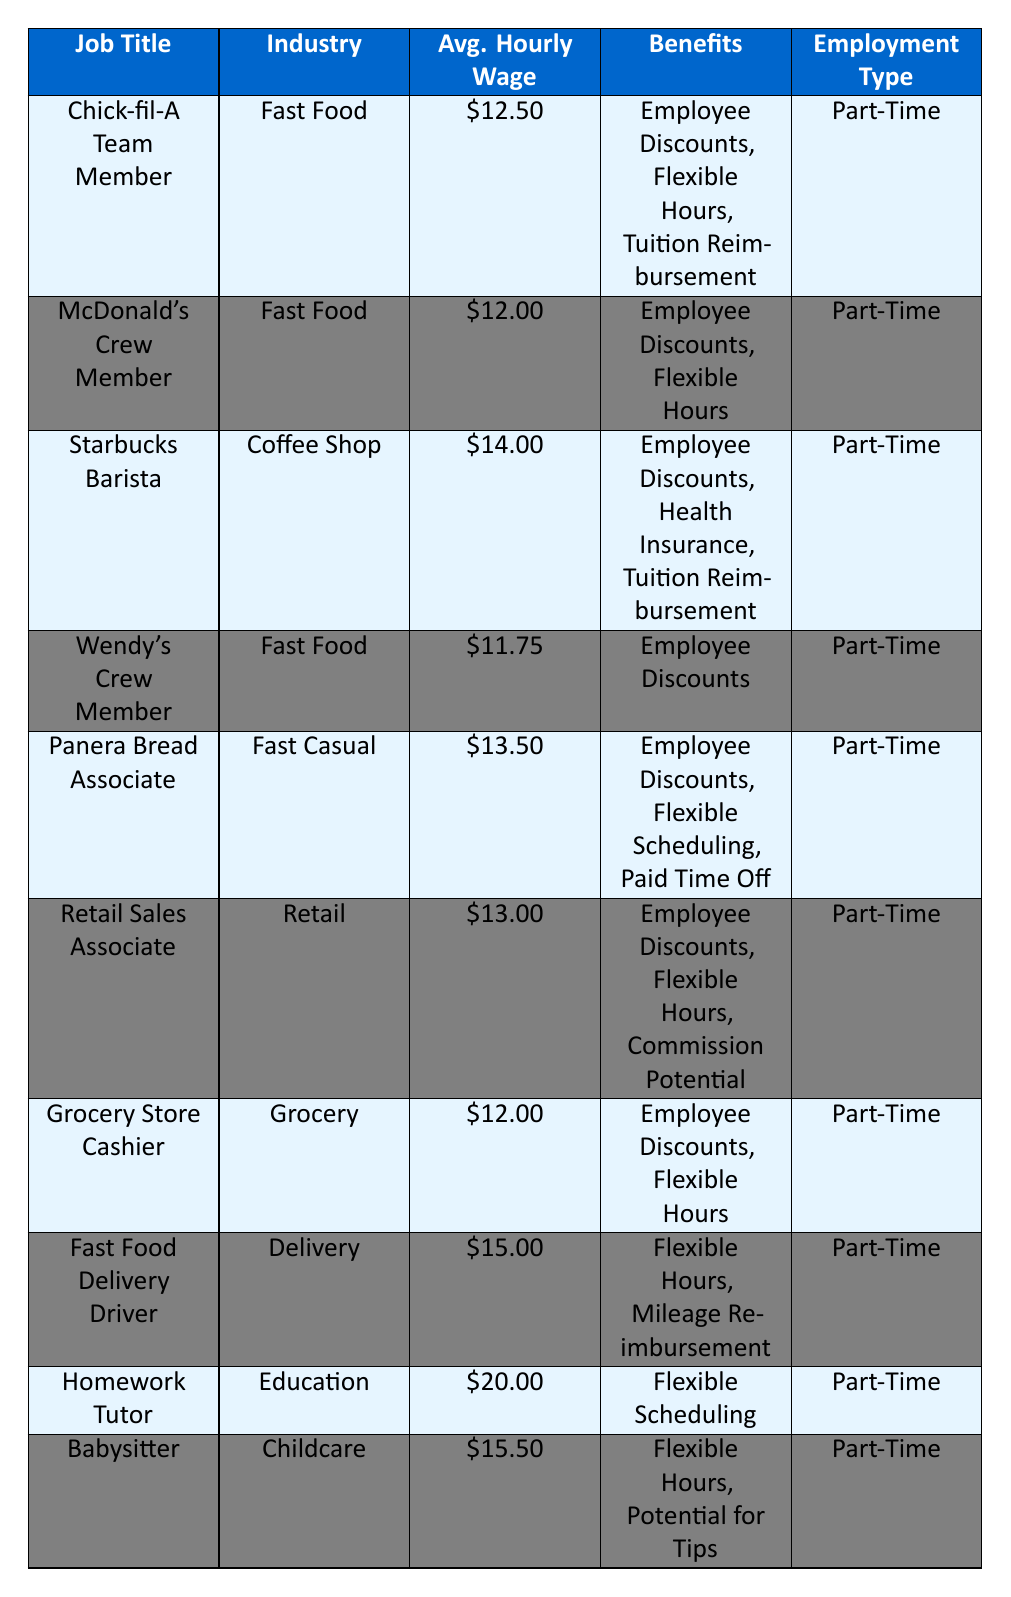What is the average hourly wage of a Chick-fil-A Team Member? The table shows that the average hourly wage for a Chick-fil-A Team Member is $12.50.
Answer: $12.50 Which position has the highest average hourly wage in the table? The Homework Tutor has the highest average hourly wage at $20.00.
Answer: Homework Tutor How much more does a Fast Food Delivery Driver earn compared to a Wendy's Crew Member? The Fast Food Delivery Driver earns $15.00 while Wendy's Crew Member earns $11.75. The difference is $15.00 - $11.75 = $3.25.
Answer: $3.25 Does Starbucks Barista offer tuition reimbursement as a benefit? Yes, the table indicates that Starbucks Barista includes tuition reimbursement in its benefits.
Answer: Yes What is the average hourly wage for all the fast food jobs listed? The fast food jobs are Chick-fil-A Team Member ($12.50), McDonald's Crew Member ($12.00), and Wendy's Crew Member ($11.75). The average is (12.50 + 12.00 + 11.75) / 3 = 12.08.
Answer: $12.08 What is the difference in average hourly wage between the highest paying job and the lowest paying job in the table? The highest paying job is Homework Tutor at $20.00, and the lowest paying job is Wendy's Crew Member at $11.75. The difference is $20.00 - $11.75 = $8.25.
Answer: $8.25 Are there any positions that offer flexible hours? Yes, multiple positions offer flexible hours, including Chick-fil-A Team Member, McDonald's Crew Member, Grocery Store Cashier, Fast Food Delivery Driver, and Babysitter.
Answer: Yes What is the total average hourly wage of all positions in the table? Summing up the average hourly wages: $12.50 + $12.00 + $14.00 + $11.75 + $13.50 + $13.00 + $12.00 + $15.00 + $20.00 + $15.50 = $138.75. There are 10 jobs, so the average is $138.75 / 10 = $13.88.
Answer: $13.88 Which industry has the second-highest average hourly wage, and what is that wage? The Coffee Shop industry (Starbucks Barista) is the second highest at $14.00, after the Education industry (Homework Tutor) at $20.00.
Answer: Coffee Shop, $14.00 Is there any job that provides paid time off? Yes, the Panera Bread Associate position provides paid time off as one of its benefits.
Answer: Yes 